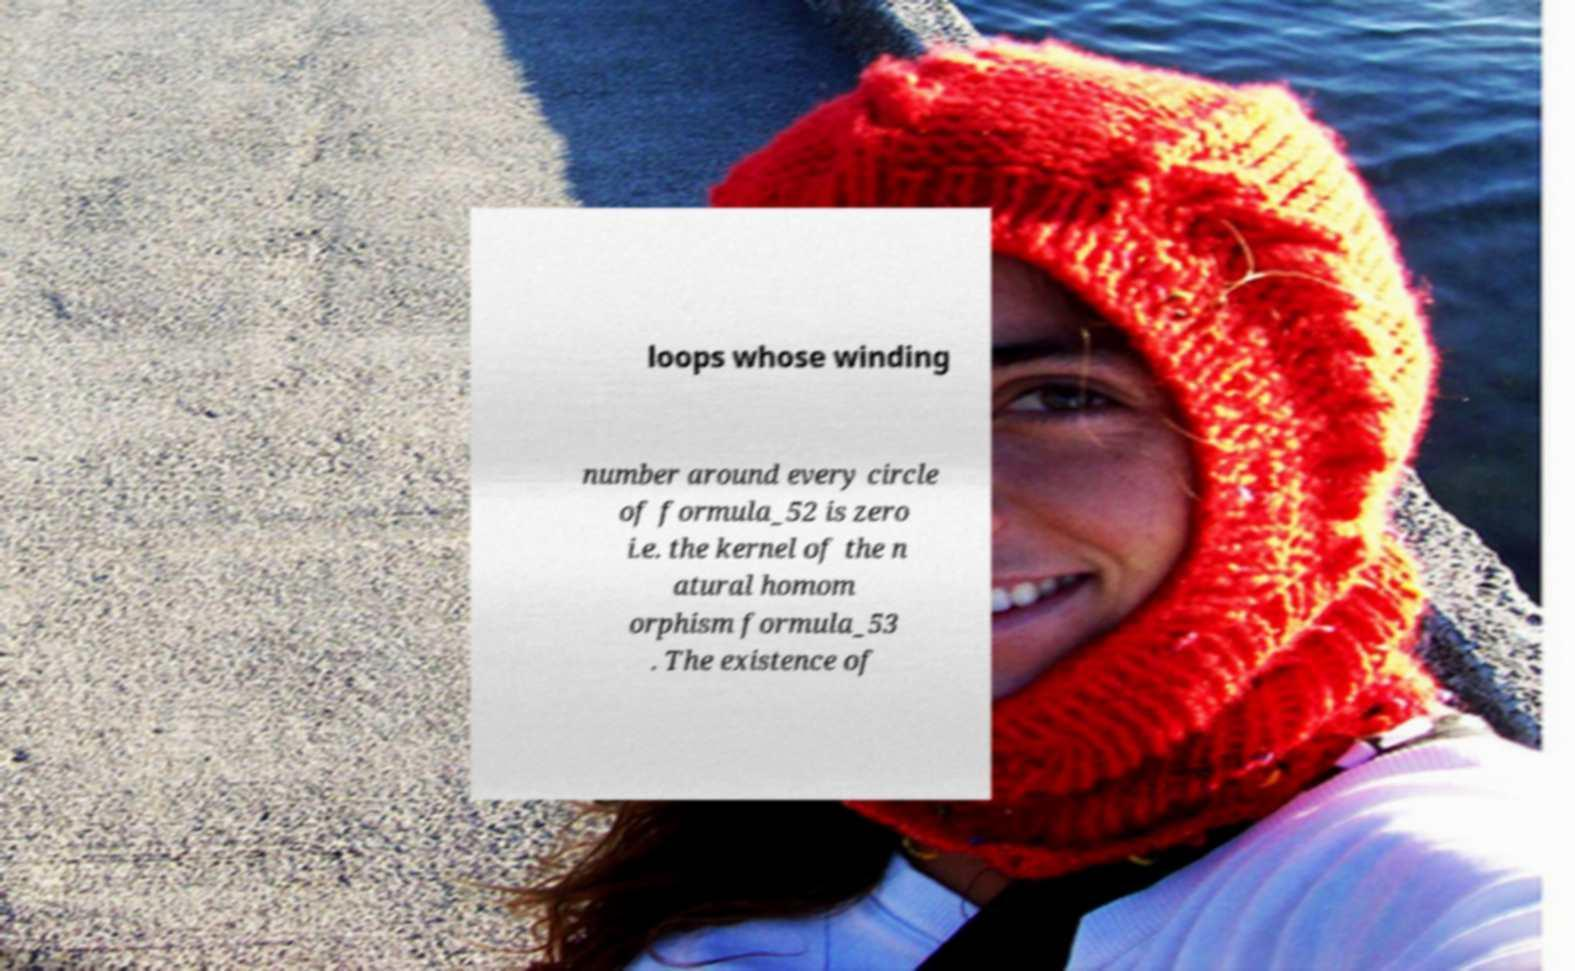Please identify and transcribe the text found in this image. loops whose winding number around every circle of formula_52 is zero i.e. the kernel of the n atural homom orphism formula_53 . The existence of 